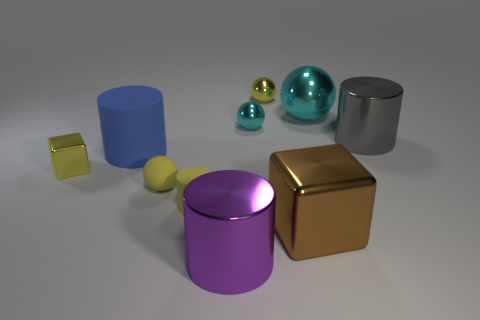Is there a sense of balance or symmetry in the arrangement of shapes? The arrangement of shapes doesn't exhibit a strict sense of balance or symmetry. The shapes are placed randomly, with varying sizes and colors, which provides a sense of organic diversity rather than structured symmetry. 